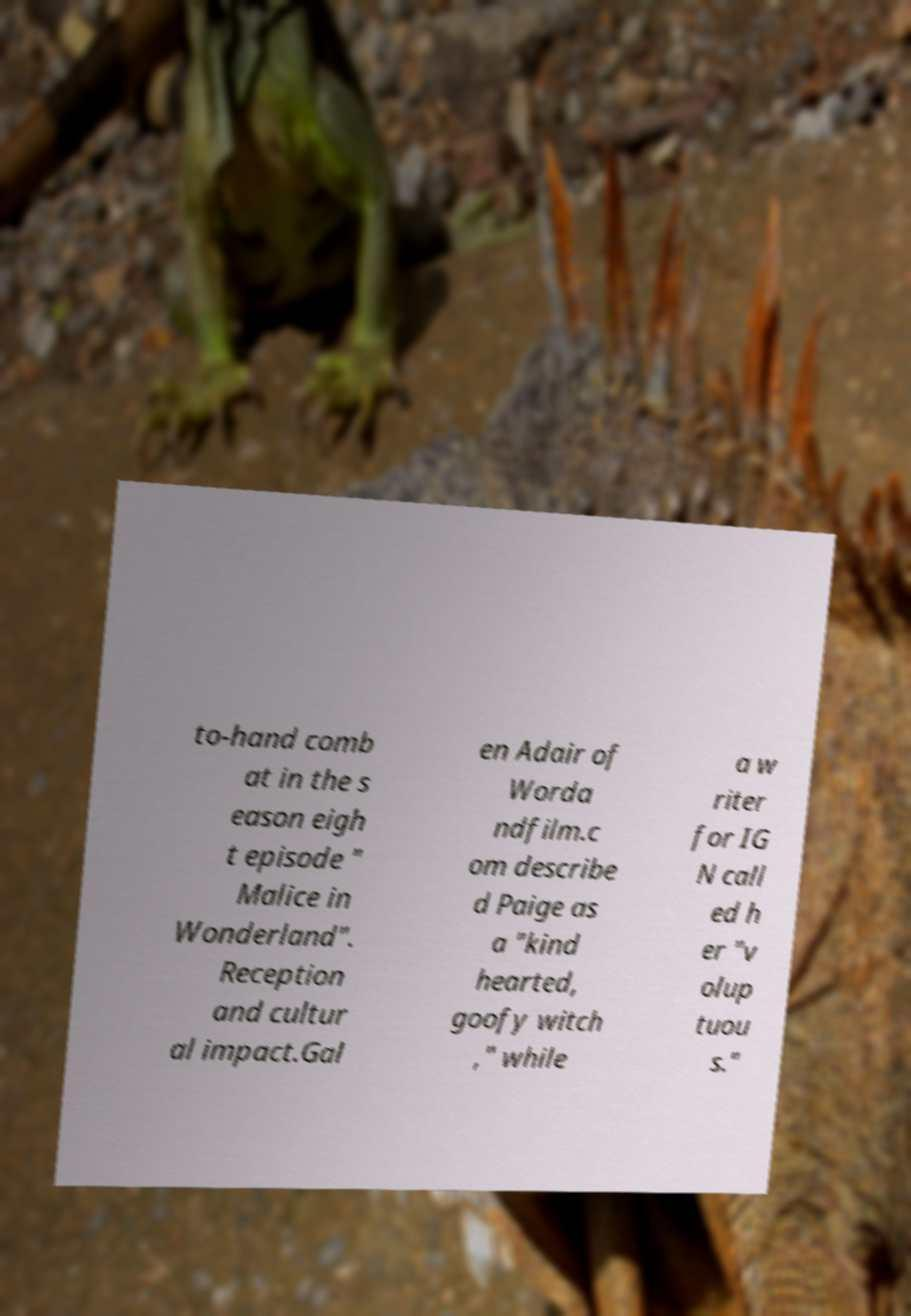What messages or text are displayed in this image? I need them in a readable, typed format. to-hand comb at in the s eason eigh t episode " Malice in Wonderland". Reception and cultur al impact.Gal en Adair of Worda ndfilm.c om describe d Paige as a "kind hearted, goofy witch ," while a w riter for IG N call ed h er "v olup tuou s." 